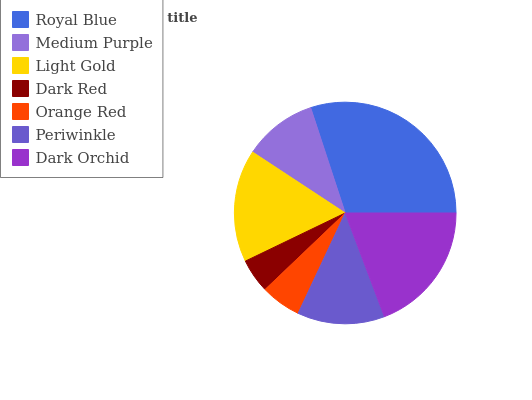Is Dark Red the minimum?
Answer yes or no. Yes. Is Royal Blue the maximum?
Answer yes or no. Yes. Is Medium Purple the minimum?
Answer yes or no. No. Is Medium Purple the maximum?
Answer yes or no. No. Is Royal Blue greater than Medium Purple?
Answer yes or no. Yes. Is Medium Purple less than Royal Blue?
Answer yes or no. Yes. Is Medium Purple greater than Royal Blue?
Answer yes or no. No. Is Royal Blue less than Medium Purple?
Answer yes or no. No. Is Periwinkle the high median?
Answer yes or no. Yes. Is Periwinkle the low median?
Answer yes or no. Yes. Is Orange Red the high median?
Answer yes or no. No. Is Royal Blue the low median?
Answer yes or no. No. 